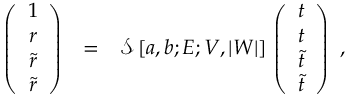<formula> <loc_0><loc_0><loc_500><loc_500>\begin{array} { c c l } { { \left ( \begin{array} { c } { 1 } \\ { r } \\ { { \tilde { r } } } \\ { { \tilde { r } } } \end{array} \right ) } } & { = } & { { \mathcal { S } \, [ a , b ; E ; V , | W | ] \, \left ( \begin{array} { c } { t } \\ { t } \\ { { \tilde { t } } } \\ { { \tilde { t } } } \end{array} \right ) , } } \end{array}</formula> 